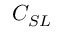<formula> <loc_0><loc_0><loc_500><loc_500>C _ { S L }</formula> 